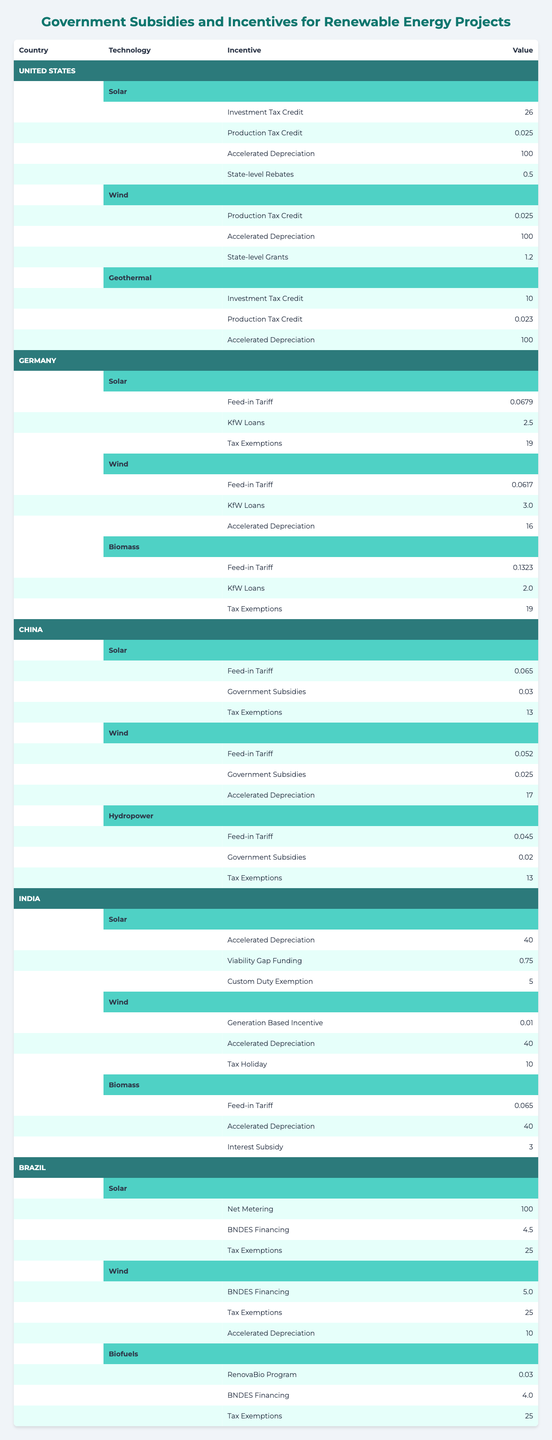What is the value of the Investment Tax Credit for solar projects in the United States? According to the table, the Investment Tax Credit for solar projects in the United States is listed as 26.
Answer: 26 Which country provides the highest incentive value for solar technology? By comparing the values for solar technology across all countries, Brazil offers a net metering incentive valued at 100, which is the highest.
Answer: Brazil (Net Metering - 100) Do all countries provide Accelerated Depreciation for wind projects? Examining the table, not all countries offer Accelerated Depreciation for wind projects; India does not have it listed for wind.
Answer: No What is the sum of the feed-in tariffs for wind projects in Germany and China? The feed-in tariff for wind projects in Germany is 0.0617 and in China is 0.052. Adding these two values together gives 0.0617 + 0.052 = 0.1137.
Answer: 0.1137 Which technology type has the highest total incentive value in the United States? Evaluating the incentive values for each technology in the United States: Solar (26 + 0.025 + 100 + 0.5 = 126.525), Wind (0.025 + 100 + 1.2 = 101.225), Geothermal (10 + 0.023 + 100 = 110.023). The highest total is for Solar at 126.525.
Answer: Solar Are there any government subsidies for hydropower in China? Checking the table, it shows that there are feed-in tariffs and other incentives for hydropower; however, no explicit mention of government subsidies is listed.
Answer: No What is the average value of KfW Loans across all countries for wind projects? KfW Loans for wind are present in Germany (3.0) and have no values listed from the other countries, so the average is just the available value of 3.0/1 = 3.0.
Answer: 3.0 Which renewable energy technology receives the most diverse set of incentives in India? Upon reviewing the table, solar technology in India has three different incentives listed (Accelerated Depreciation, Viability Gap Funding, Custom Duty Exemption) while wind and biomass have only two each.
Answer: Solar What percentage of total incentives does the Production Tax Credit represent for wind projects in the United States? The total incentives for wind projects in the US are 0.025 (Production Tax Credit) + 100 (Accelerated Depreciation) + 1.2 (State-level Grants) = 101.225. The Production Tax Credit accounts for 0.025/101.225, which is approximately 0.0247 or 2.47%.
Answer: 2.47% Is there a tax holiday incentive for solar projects in India? By checking the table, there is no mention of a tax holiday incentive for solar projects in India; it only lists incentives for wind and biomass under that category.
Answer: No 